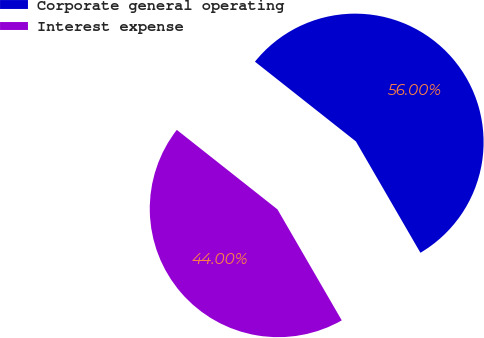Convert chart to OTSL. <chart><loc_0><loc_0><loc_500><loc_500><pie_chart><fcel>Corporate general operating<fcel>Interest expense<nl><fcel>56.0%<fcel>44.0%<nl></chart> 